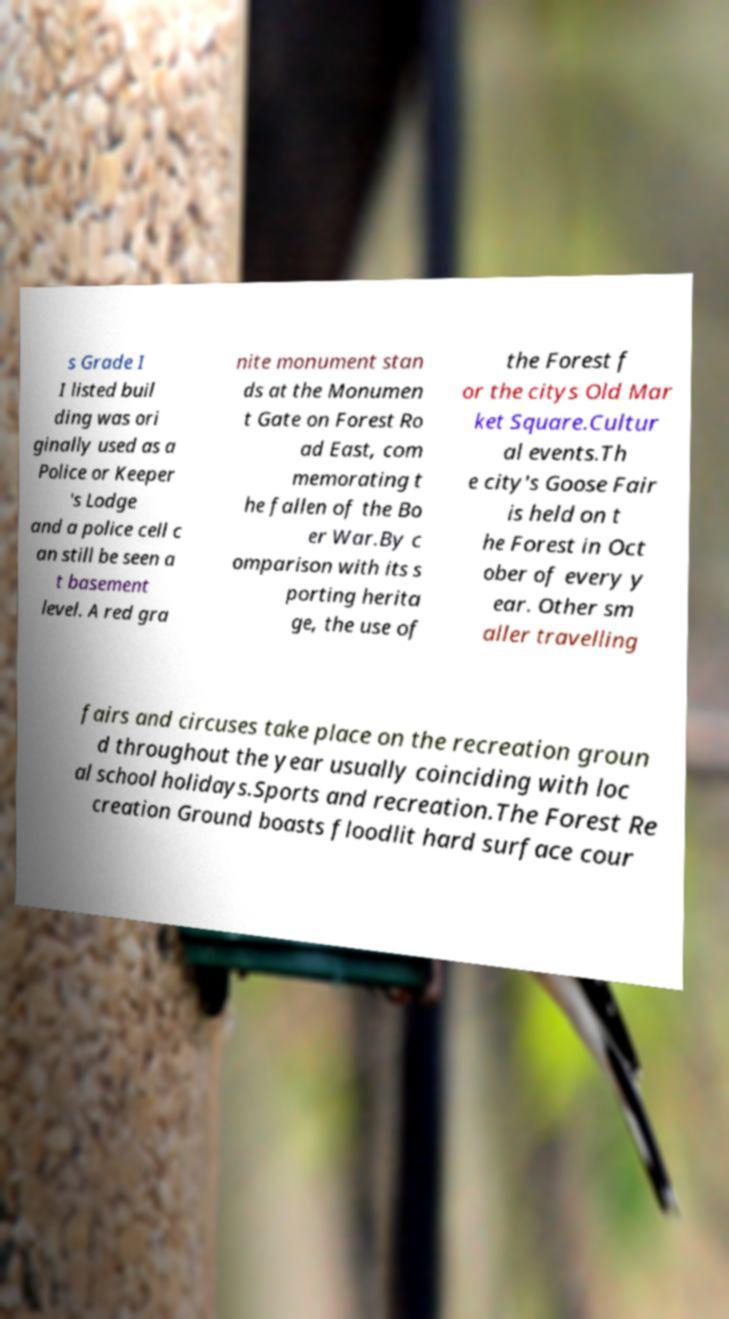I need the written content from this picture converted into text. Can you do that? s Grade I I listed buil ding was ori ginally used as a Police or Keeper 's Lodge and a police cell c an still be seen a t basement level. A red gra nite monument stan ds at the Monumen t Gate on Forest Ro ad East, com memorating t he fallen of the Bo er War.By c omparison with its s porting herita ge, the use of the Forest f or the citys Old Mar ket Square.Cultur al events.Th e city's Goose Fair is held on t he Forest in Oct ober of every y ear. Other sm aller travelling fairs and circuses take place on the recreation groun d throughout the year usually coinciding with loc al school holidays.Sports and recreation.The Forest Re creation Ground boasts floodlit hard surface cour 